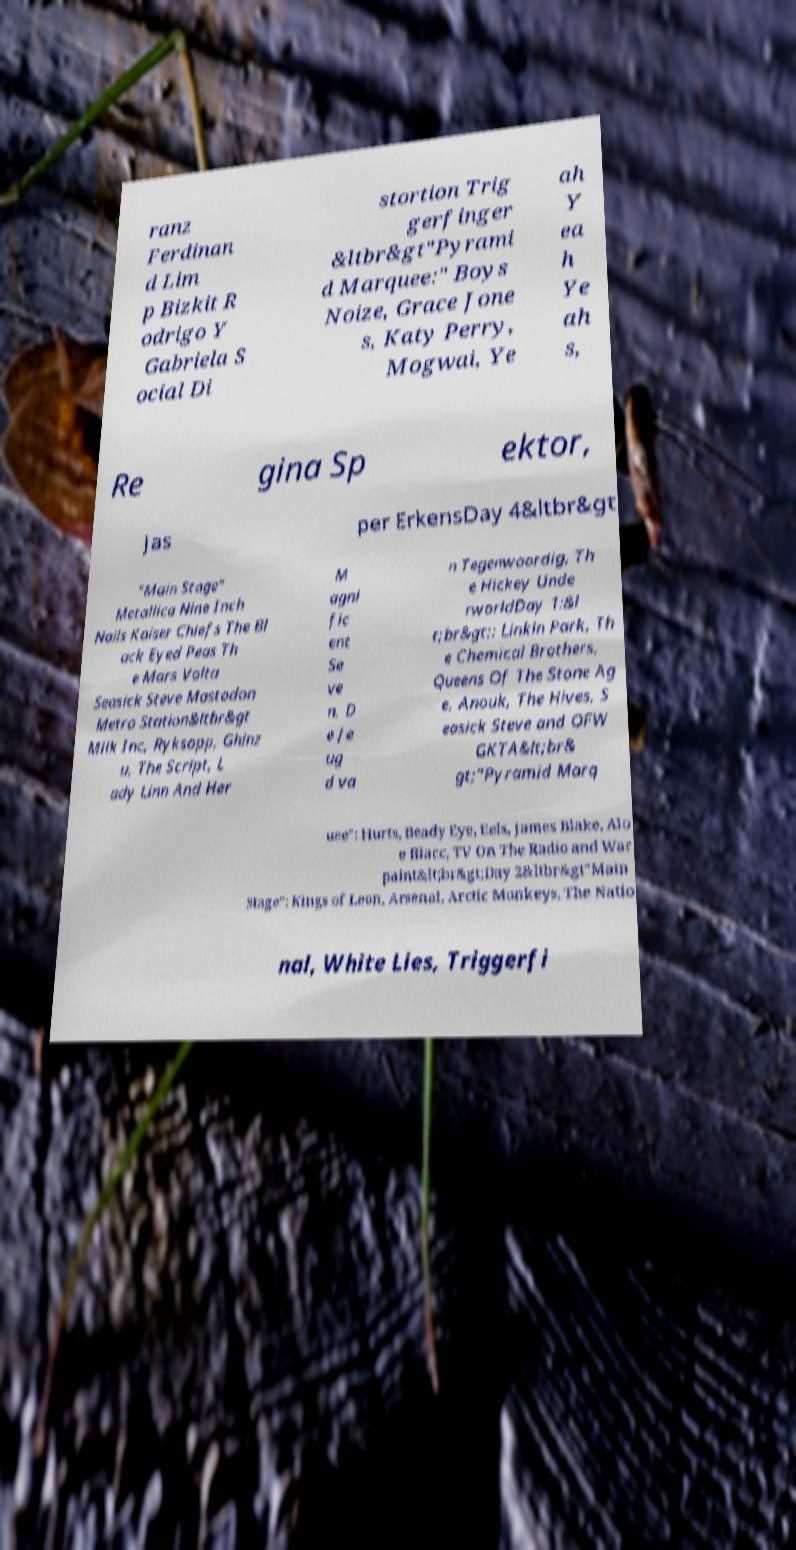Please read and relay the text visible in this image. What does it say? ranz Ferdinan d Lim p Bizkit R odrigo Y Gabriela S ocial Di stortion Trig gerfinger &ltbr&gt"Pyrami d Marquee:" Boys Noize, Grace Jone s, Katy Perry, Mogwai, Ye ah Y ea h Ye ah s, Re gina Sp ektor, Jas per ErkensDay 4&ltbr&gt "Main Stage" Metallica Nine Inch Nails Kaiser Chiefs The Bl ack Eyed Peas Th e Mars Volta Seasick Steve Mastodon Metro Station&ltbr&gt Milk Inc, Ryksopp, Ghinz u, The Script, L ady Linn And Her M agni fic ent Se ve n, D e Je ug d va n Tegenwoordig, Th e Hickey Unde rworldDay 1:&l t;br&gt;: Linkin Park, Th e Chemical Brothers, Queens Of The Stone Ag e, Anouk, The Hives, S easick Steve and OFW GKTA&lt;br& gt;"Pyramid Marq uee": Hurts, Beady Eye, Eels, James Blake, Alo e Blacc, TV On The Radio and War paint&lt;br&gt;Day 2&ltbr&gt"Main Stage": Kings of Leon, Arsenal, Arctic Monkeys, The Natio nal, White Lies, Triggerfi 